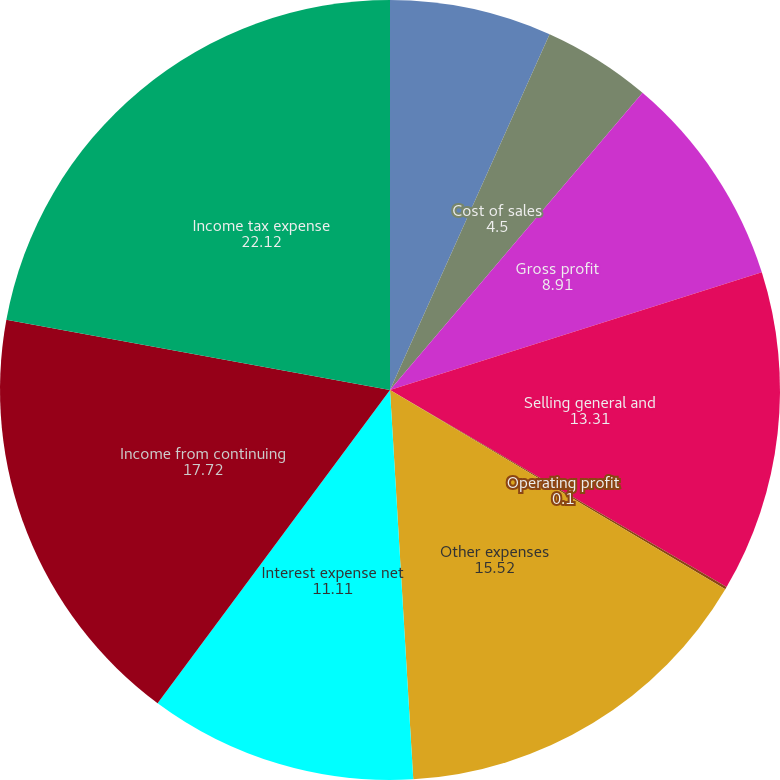Convert chart to OTSL. <chart><loc_0><loc_0><loc_500><loc_500><pie_chart><fcel>Net sales<fcel>Cost of sales<fcel>Gross profit<fcel>Selling general and<fcel>Operating profit<fcel>Other expenses<fcel>Interest expense net<fcel>Income from continuing<fcel>Income tax expense<nl><fcel>6.71%<fcel>4.5%<fcel>8.91%<fcel>13.31%<fcel>0.1%<fcel>15.52%<fcel>11.11%<fcel>17.72%<fcel>22.12%<nl></chart> 